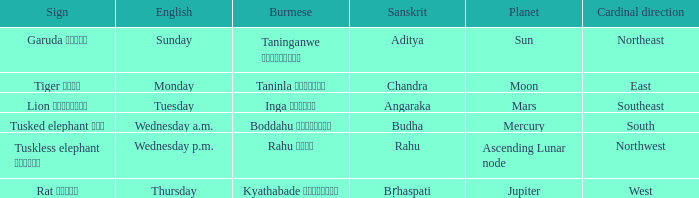State the name of day in english where cardinal direction is east Monday. 